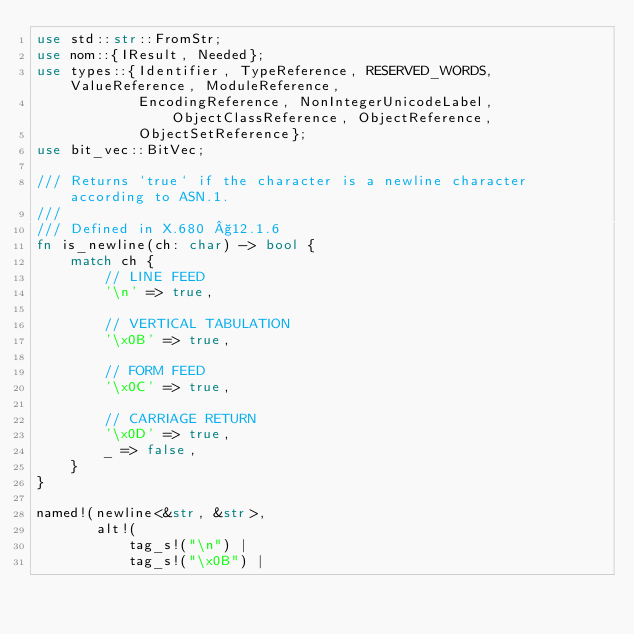Convert code to text. <code><loc_0><loc_0><loc_500><loc_500><_Rust_>use std::str::FromStr;
use nom::{IResult, Needed};
use types::{Identifier, TypeReference, RESERVED_WORDS, ValueReference, ModuleReference,
            EncodingReference, NonIntegerUnicodeLabel, ObjectClassReference, ObjectReference,
            ObjectSetReference};
use bit_vec::BitVec;

/// Returns `true` if the character is a newline character according to ASN.1.
///
/// Defined in X.680 §12.1.6
fn is_newline(ch: char) -> bool {
    match ch {
        // LINE FEED
        '\n' => true,

        // VERTICAL TABULATION
        '\x0B' => true,

        // FORM FEED
        '\x0C' => true,

        // CARRIAGE RETURN
        '\x0D' => true,
        _ => false,
    }
}

named!(newline<&str, &str>,
       alt!(
           tag_s!("\n") |
           tag_s!("\x0B") |</code> 